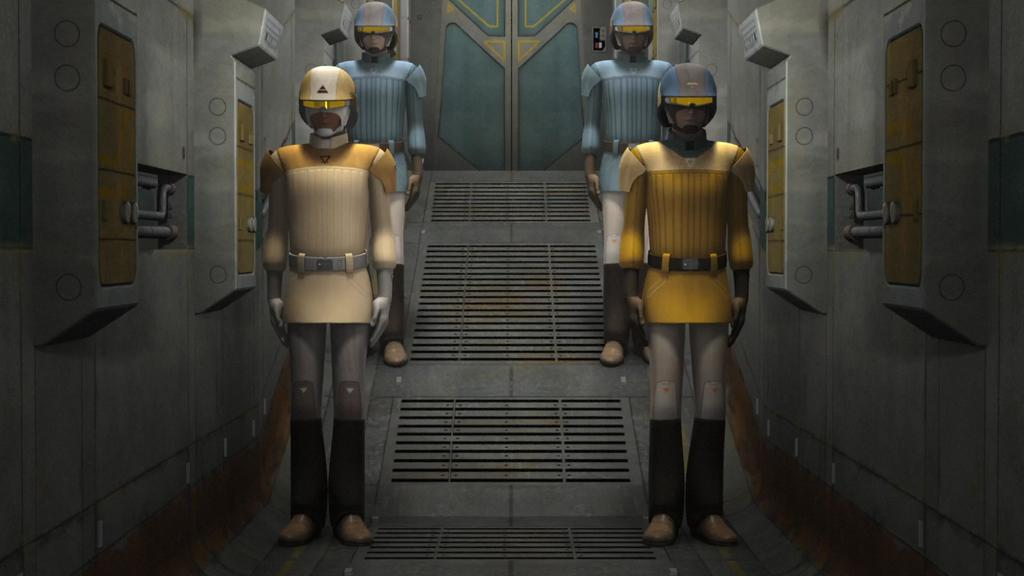What type of characters are present in the image? The image contains animated depictions of persons. Can you describe the setting of the image? There is a door in the background of the image. Where is the kitten located in the image? There is no kitten present in the image. How many oranges are visible in the middle of the image? There are no oranges present in the image. 